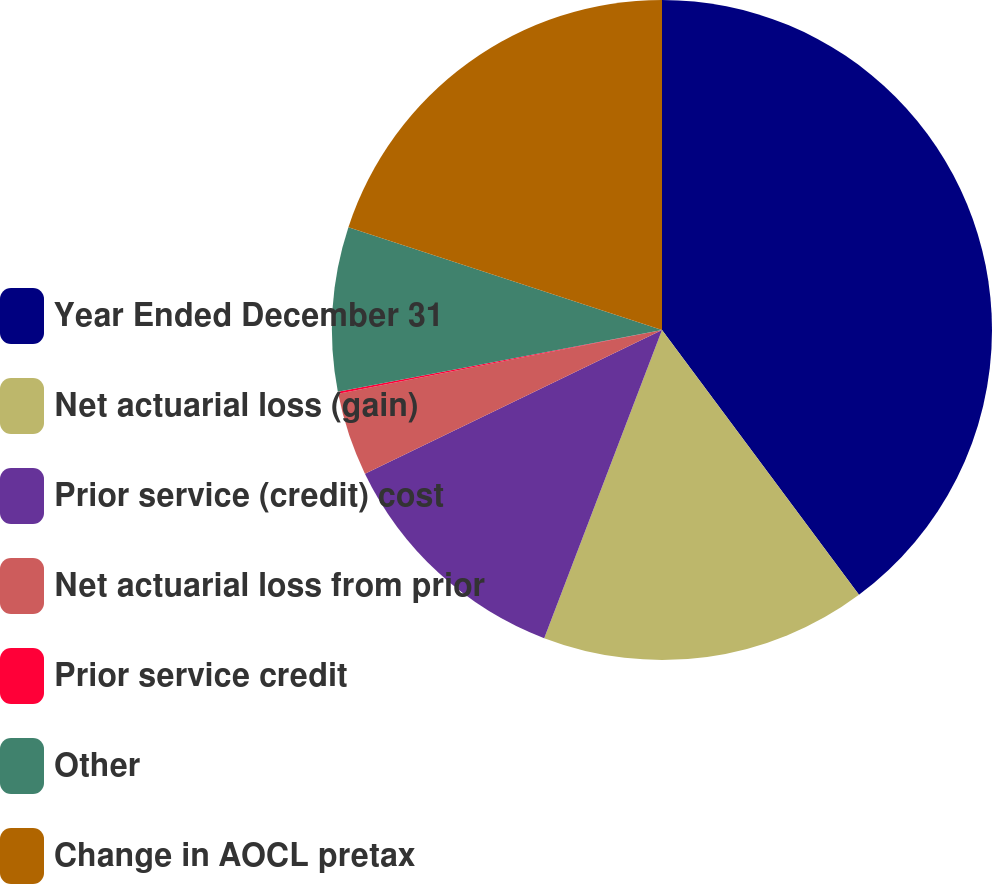Convert chart. <chart><loc_0><loc_0><loc_500><loc_500><pie_chart><fcel>Year Ended December 31<fcel>Net actuarial loss (gain)<fcel>Prior service (credit) cost<fcel>Net actuarial loss from prior<fcel>Prior service credit<fcel>Other<fcel>Change in AOCL pretax<nl><fcel>39.82%<fcel>15.99%<fcel>12.02%<fcel>4.07%<fcel>0.1%<fcel>8.04%<fcel>19.96%<nl></chart> 